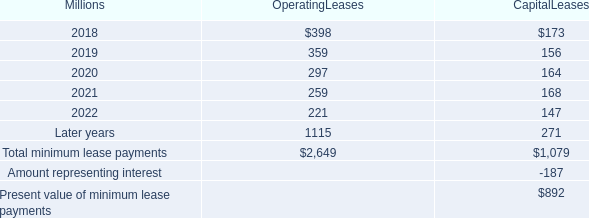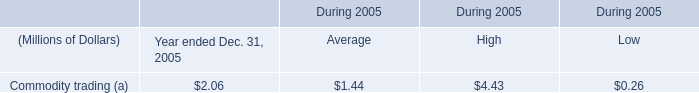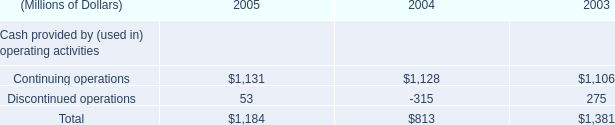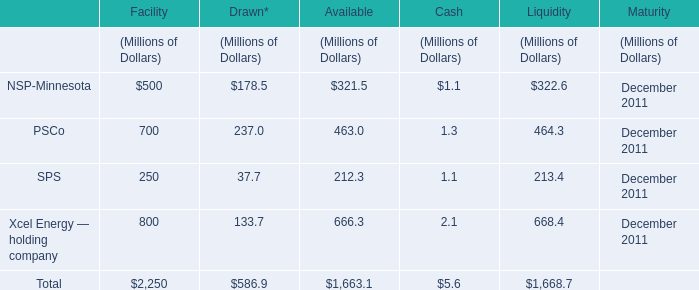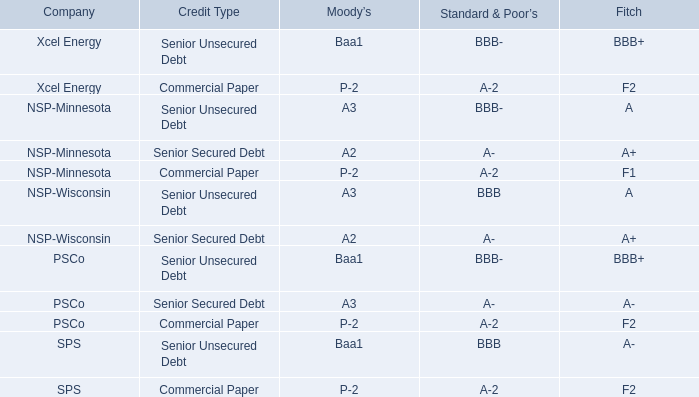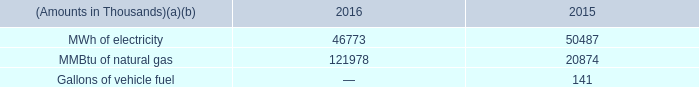what's the total amount of Continuing operations of 2003, and MWh of electricity of 2015 ? 
Computations: (1106.0 + 50487.0)
Answer: 51593.0. 